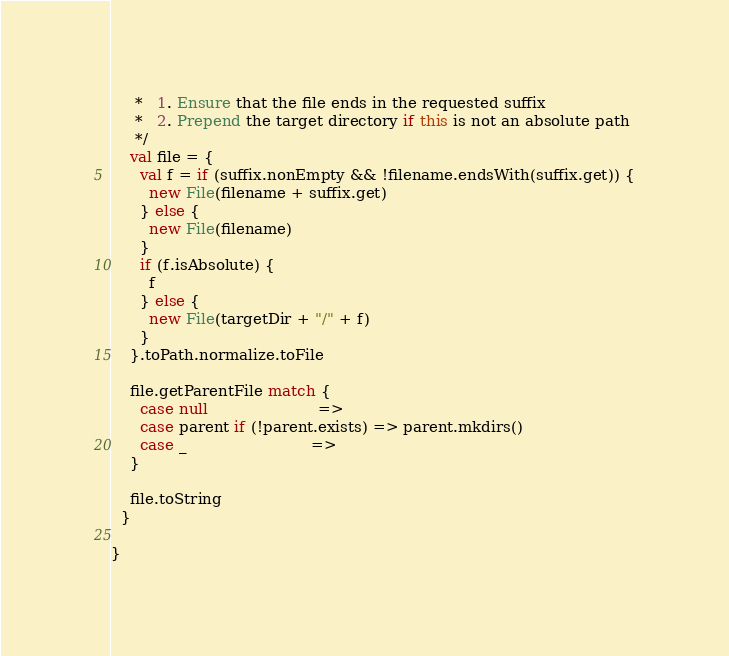<code> <loc_0><loc_0><loc_500><loc_500><_Scala_>     *   1. Ensure that the file ends in the requested suffix
     *   2. Prepend the target directory if this is not an absolute path
     */
    val file = {
      val f = if (suffix.nonEmpty && !filename.endsWith(suffix.get)) {
        new File(filename + suffix.get)
      } else {
        new File(filename)
      }
      if (f.isAbsolute) {
        f
      } else {
        new File(targetDir + "/" + f)
      }
    }.toPath.normalize.toFile

    file.getParentFile match {
      case null                       =>
      case parent if (!parent.exists) => parent.mkdirs()
      case _                          =>
    }

    file.toString
  }

}
</code> 